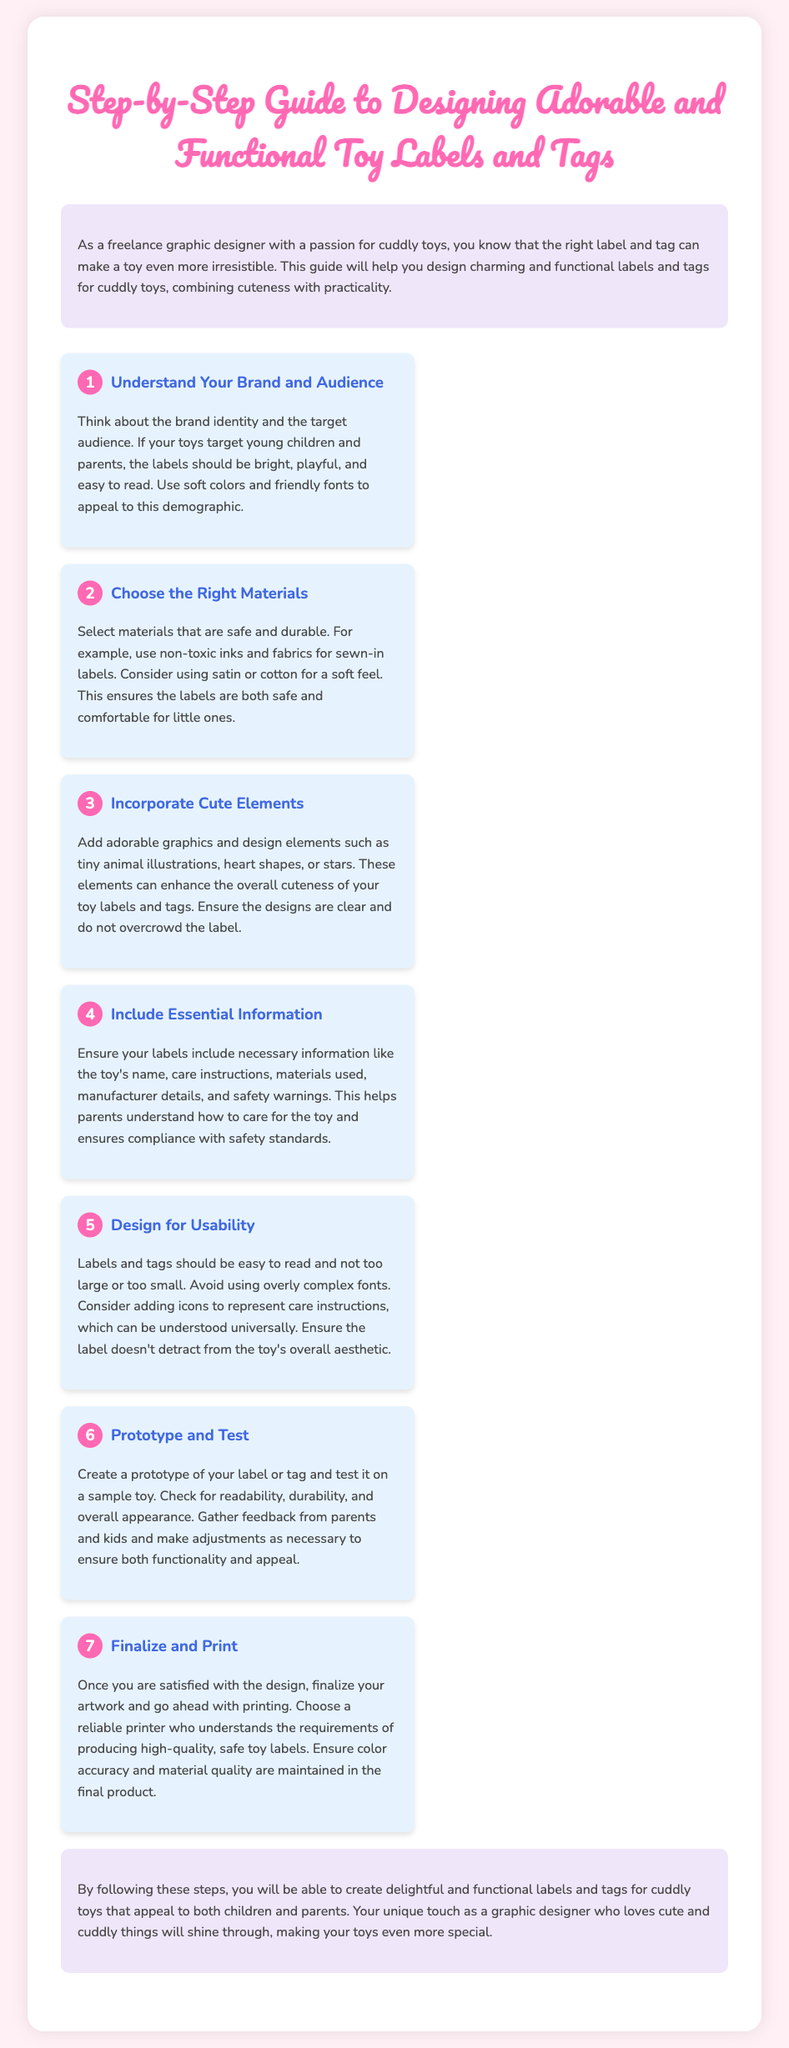What is the title of the guide? The title is prominently displayed at the top of the document and introduces the main topic of the guide.
Answer: Step-by-Step Guide to Designing Adorable and Functional Toy Labels and Tags How many steps are there in the guide? By counting the steps listed in the document, the total number can be determined.
Answer: 7 What color is the background of the body? The body of the document has a light pink background color that enhances the visual appeal.
Answer: #FFF0F5 What should labels include for toys? The guide specifies necessary information that should be featured on the labels, helping to educate the audience on their importance.
Answer: Name, care instructions, materials used, manufacturer details, safety warnings What is the first step in the guide? The first step is clearly stated at the beginning of the steps section of the guide, laying the foundation for the design process.
Answer: Understand Your Brand and Audience Why is it important to prototype and test? The guide explains the significance of this process in ensuring the labels function as intended and meet expectations.
Answer: To check readability, durability, and overall appearance What should be avoided in label design according to the guide? The document outlines best practices and pitfalls to avoid during the design process.
Answer: Overly complex fonts What materials are recommended for labels? The guide advises on suitable materials based on safety for children and comfort in use.
Answer: Non-toxic inks and fabrics 